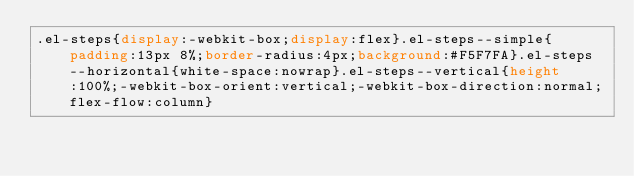<code> <loc_0><loc_0><loc_500><loc_500><_CSS_>.el-steps{display:-webkit-box;display:flex}.el-steps--simple{padding:13px 8%;border-radius:4px;background:#F5F7FA}.el-steps--horizontal{white-space:nowrap}.el-steps--vertical{height:100%;-webkit-box-orient:vertical;-webkit-box-direction:normal;flex-flow:column}</code> 